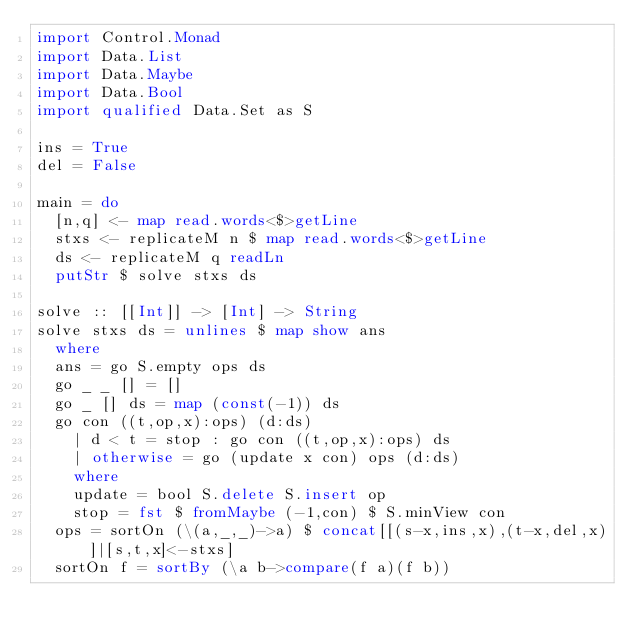<code> <loc_0><loc_0><loc_500><loc_500><_Haskell_>import Control.Monad
import Data.List
import Data.Maybe
import Data.Bool
import qualified Data.Set as S

ins = True
del = False

main = do
  [n,q] <- map read.words<$>getLine
  stxs <- replicateM n $ map read.words<$>getLine
  ds <- replicateM q readLn
  putStr $ solve stxs ds

solve :: [[Int]] -> [Int] -> String
solve stxs ds = unlines $ map show ans
  where
  ans = go S.empty ops ds
  go _ _ [] = []
  go _ [] ds = map (const(-1)) ds
  go con ((t,op,x):ops) (d:ds)
    | d < t = stop : go con ((t,op,x):ops) ds
    | otherwise = go (update x con) ops (d:ds)
    where
    update = bool S.delete S.insert op
    stop = fst $ fromMaybe (-1,con) $ S.minView con
  ops = sortOn (\(a,_,_)->a) $ concat[[(s-x,ins,x),(t-x,del,x)]|[s,t,x]<-stxs]
  sortOn f = sortBy (\a b->compare(f a)(f b))</code> 